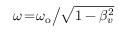<formula> <loc_0><loc_0><loc_500><loc_500>\omega \, = \, \omega _ { o } \Big / \sqrt { 1 - \beta _ { v } ^ { 2 } }</formula> 